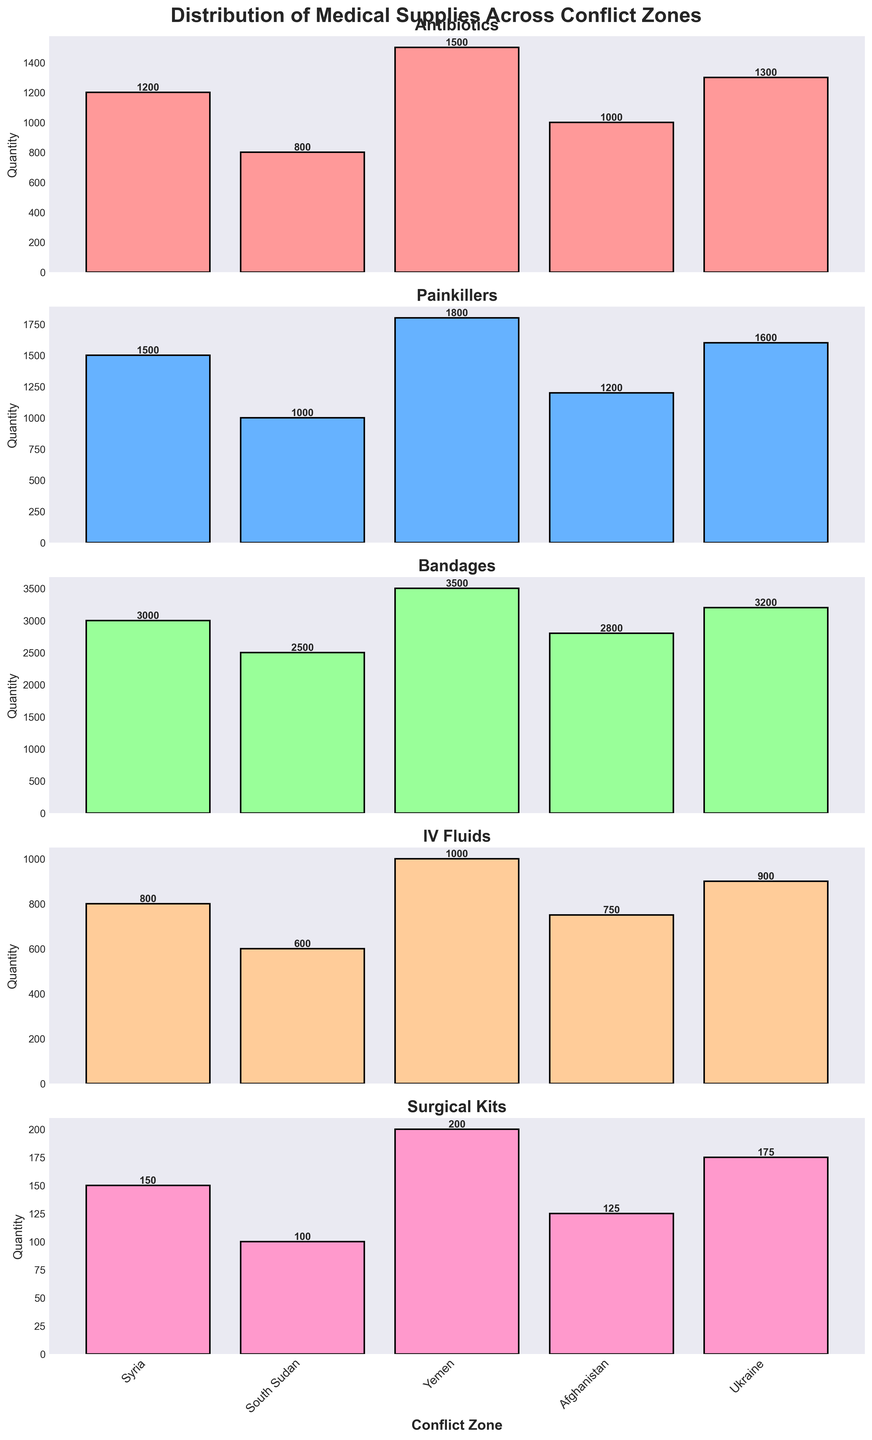Which conflict zone has the highest quantity of Painkillers? By examining the vertical subplot for Painkillers, we identify the bar that reaches the highest point. In this subplot, Yemen's bar is the tallest, indicating it has the highest quantity.
Answer: Yemen How many types of medical supplies are displayed in the figure? The figure contains 5 vertical subplots, each representing a different type of medical supply: Antibiotics, Painkillers, Bandages, IV Fluids, and Surgical Kits.
Answer: 5 What is the difference in the quantity of Bandages distributed between Syria and Yemen? In the subplot for Bandages, Syria has 3000 units, and Yemen has 3500 units. The difference is calculated as 3500 - 3000.
Answer: 500 Which conflict zone has the lowest quantity of IV Fluids? By looking at the subplot for IV Fluids, we compare the height of each bar. South Sudan has the lowest bar height at 600 units.
Answer: South Sudan Which supply type has the most evenly distributed quantities across all conflict zones? By comparing the subplots, we observe the variance in the bar heights. Surgical Kits appear most even, ranging from 100 to 200, with less disparity compared to other supplies.
Answer: Surgical Kits What is the total quantity of Surgical Kits distributed across all conflict zones? Add the quantities of Surgical Kits: 150 (Syria) + 100 (South Sudan) + 200 (Yemen) + 125 (Afghanistan) + 175 (Ukraine). This sum is the total number of Surgical Kits distributed.
Answer: 750 What is the average quantity of Antibiotics distributed among the conflict zones? Sum the quantities of Antibiotics: 1200 (Syria) + 800 (South Sudan) + 1500 (Yemen) + 1000 (Afghanistan) + 1300 (Ukraine), and divide by the number of conflict zones (5).
Answer: 1160 Is there any conflict zone that has the highest quantity in more than one type of supply? By checking each subplot, Yemen has the highest quantities in Painkillers and Bandages.
Answer: Yes, Yemen Which conflict zone received more IV Fluids than Antibiotics? Compare the quantities of IV Fluids and Antibiotics for each zone. Ukraine received 900 IV Fluids and 1300 Antibiotics—not higher. Yemen received 1000 IV Fluids and 1500 Antibiotics—not higher. Afghanistan received 750 IV Fluids and 1000 Antibiotics—not higher. South Sudan received 600 IV Fluids and 800 Antibiotics—not higher. Syria received 800 IV Fluids and 1200 Antibiotics—not higher. No zone received more IV Fluids than Antibiotics.
Answer: None 